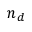Convert formula to latex. <formula><loc_0><loc_0><loc_500><loc_500>n _ { d }</formula> 